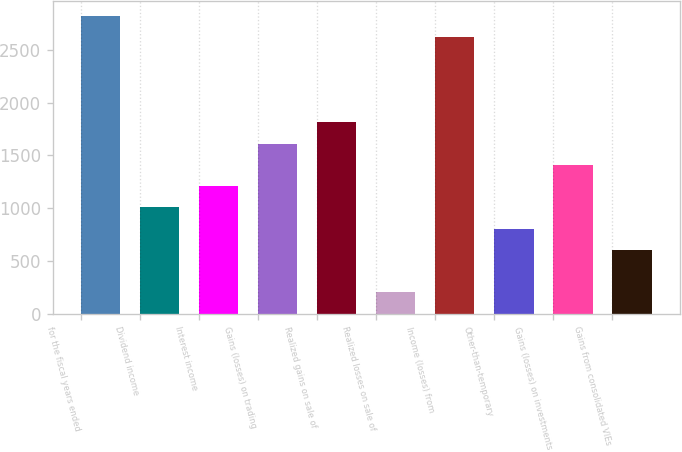Convert chart to OTSL. <chart><loc_0><loc_0><loc_500><loc_500><bar_chart><fcel>for the fiscal years ended<fcel>Dividend income<fcel>Interest income<fcel>Gains (losses) on trading<fcel>Realized gains on sale of<fcel>Realized losses on sale of<fcel>Income (losses) from<fcel>Other-than-temporary<fcel>Gains (losses) on investments<fcel>Gains from consolidated VIEs<nl><fcel>2820.68<fcel>1007.9<fcel>1209.32<fcel>1612.16<fcel>1813.58<fcel>202.22<fcel>2619.26<fcel>806.48<fcel>1410.74<fcel>605.06<nl></chart> 